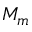Convert formula to latex. <formula><loc_0><loc_0><loc_500><loc_500>M _ { m }</formula> 